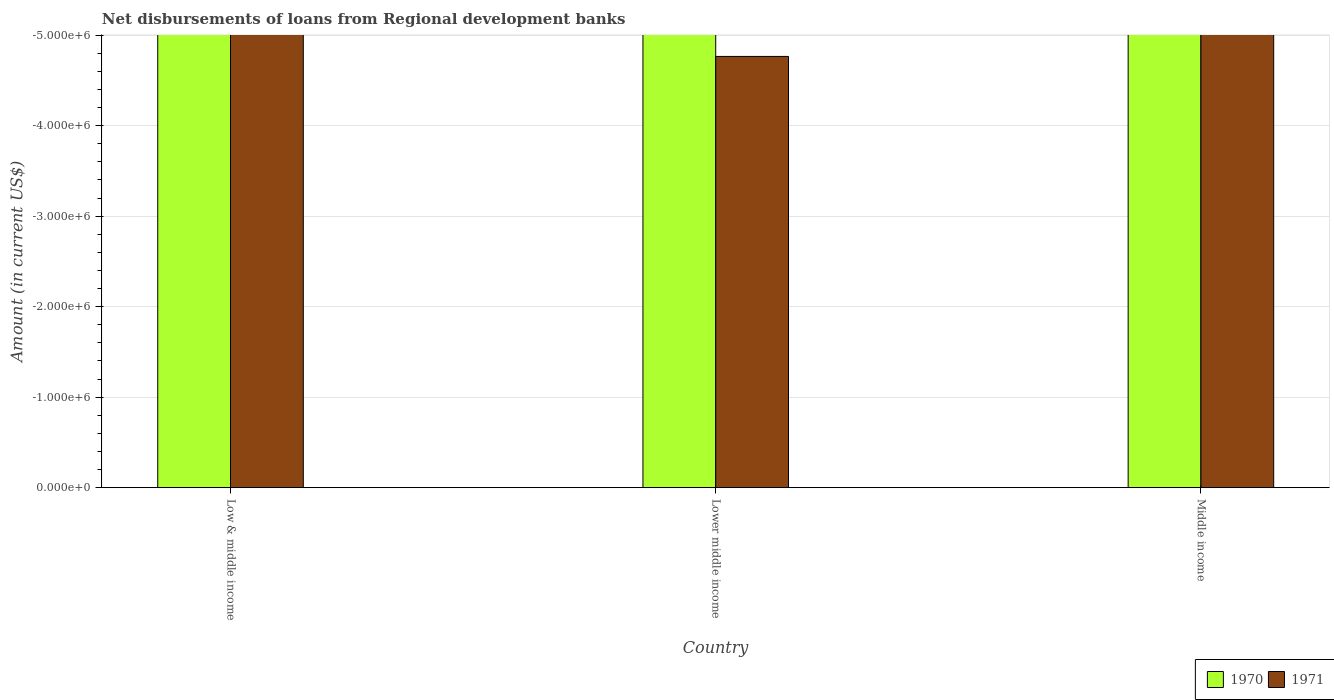How many different coloured bars are there?
Provide a succinct answer. 0. Are the number of bars on each tick of the X-axis equal?
Your answer should be very brief. Yes. What is the label of the 2nd group of bars from the left?
Ensure brevity in your answer.  Lower middle income. In how many cases, is the number of bars for a given country not equal to the number of legend labels?
Ensure brevity in your answer.  3. What is the difference between the amount of disbursements of loans from regional development banks in 1970 in Middle income and the amount of disbursements of loans from regional development banks in 1971 in Low & middle income?
Offer a terse response. 0. What is the average amount of disbursements of loans from regional development banks in 1970 per country?
Provide a succinct answer. 0. How many bars are there?
Your answer should be compact. 0. Are all the bars in the graph horizontal?
Your answer should be very brief. No. Are the values on the major ticks of Y-axis written in scientific E-notation?
Give a very brief answer. Yes. Does the graph contain any zero values?
Provide a short and direct response. Yes. Does the graph contain grids?
Your response must be concise. Yes. What is the title of the graph?
Your answer should be compact. Net disbursements of loans from Regional development banks. What is the label or title of the Y-axis?
Your answer should be compact. Amount (in current US$). What is the Amount (in current US$) in 1970 in Lower middle income?
Your answer should be compact. 0. What is the total Amount (in current US$) in 1970 in the graph?
Ensure brevity in your answer.  0. What is the average Amount (in current US$) of 1971 per country?
Offer a very short reply. 0. 